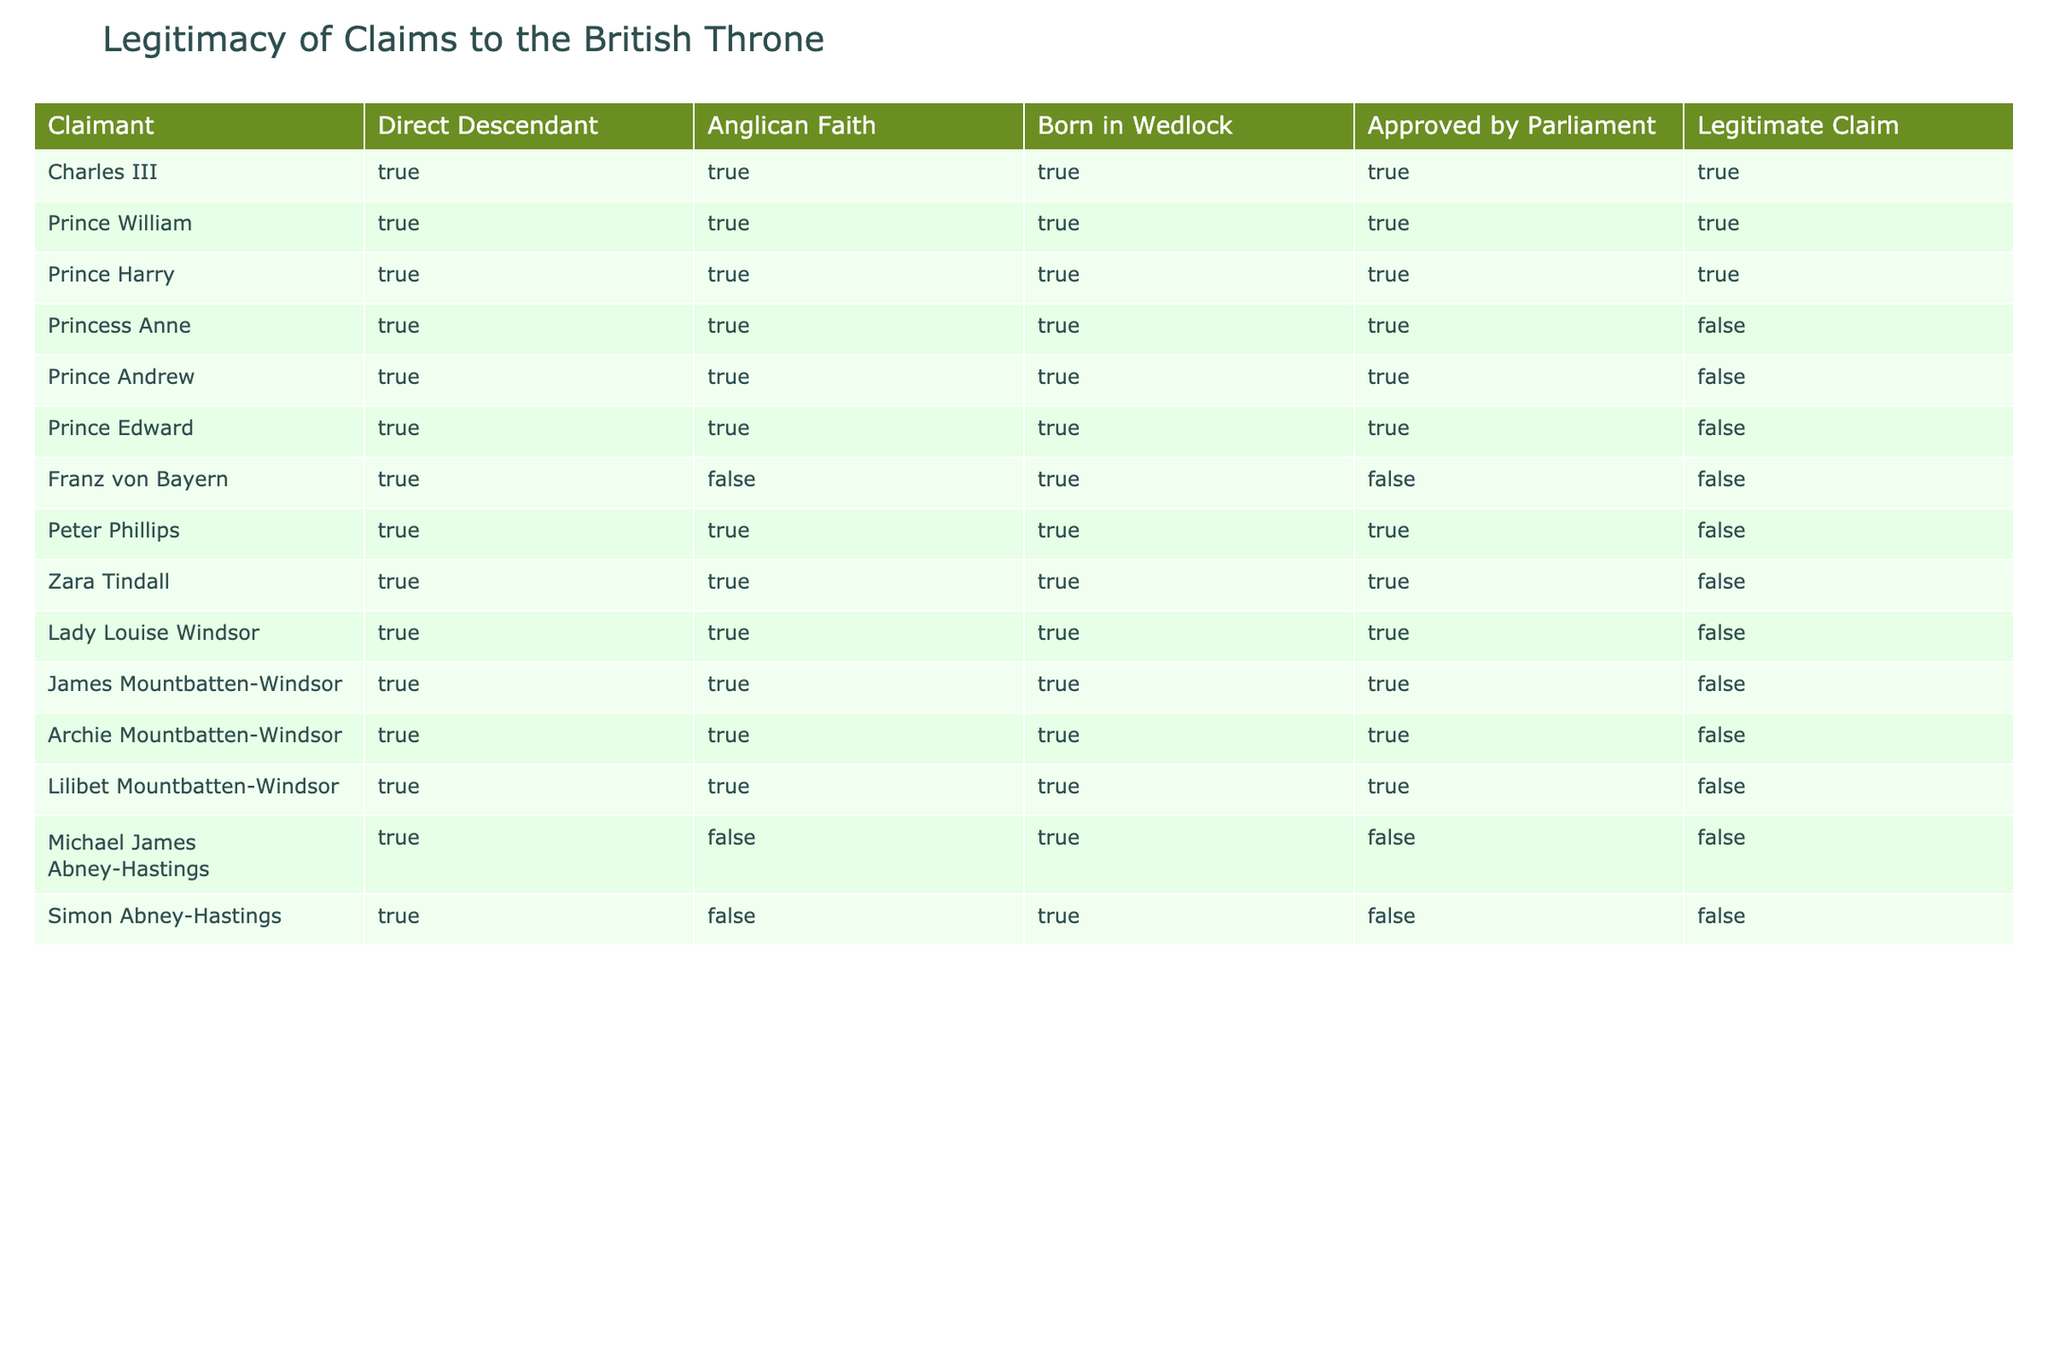What is the total number of legitimate claims to the British throne? By looking for the "Legitimate Claim" column in the table, I count how many entries have TRUE. In this case, there are 3 such entries: Charles III, Prince William, and Prince Harry.
Answer: 3 Which claimant is a direct descendant and also an Anglican but does not have a legitimate claim? By checking the "Direct Descendant" and "Anglican Faith" columns, I look for those with TRUE in both but FALSE in the "Legitimate Claim" column. The claimants are Princess Anne, Prince Andrew, and Prince Edward. Therefore, any of them can be considered correct.
Answer: Princess Anne, Prince Andrew, or Prince Edward Is Michael James Abney-Hastings a legitimate claimant to the British throne? I can directly look at the "Legitimate Claim" column for Michael James Abney-Hastings and see that it is marked as FALSE.
Answer: No How many claimants were born in wedlock but are not considered legitimate? I will check the "Born in Wedlock" column for TRUE entries and the "Legitimate Claim" column for FALSE. The claimants matching this criteria are Princess Anne, Prince Andrew, Prince Edward, Peter Phillips, Zara Tindall, Lady Louise Windsor, James Mountbatten-Windsor, Archie Mountbatten-Windsor, and Lilibet Mountbatten-Windsor, totaling 9.
Answer: 9 What percentage of claimants are both direct descendants and approved by Parliament? To find this percentage, I need to count the total claimants, which is 15, and how many are TRUE under both "Direct Descendant" and "Approved by Parliament." This number is 12 (all except Franz von Bayern, Michael James Abney-Hastings, and Simon Abney-Hastings). Therefore, (12/15) * 100 gives me 80%.
Answer: 80% 